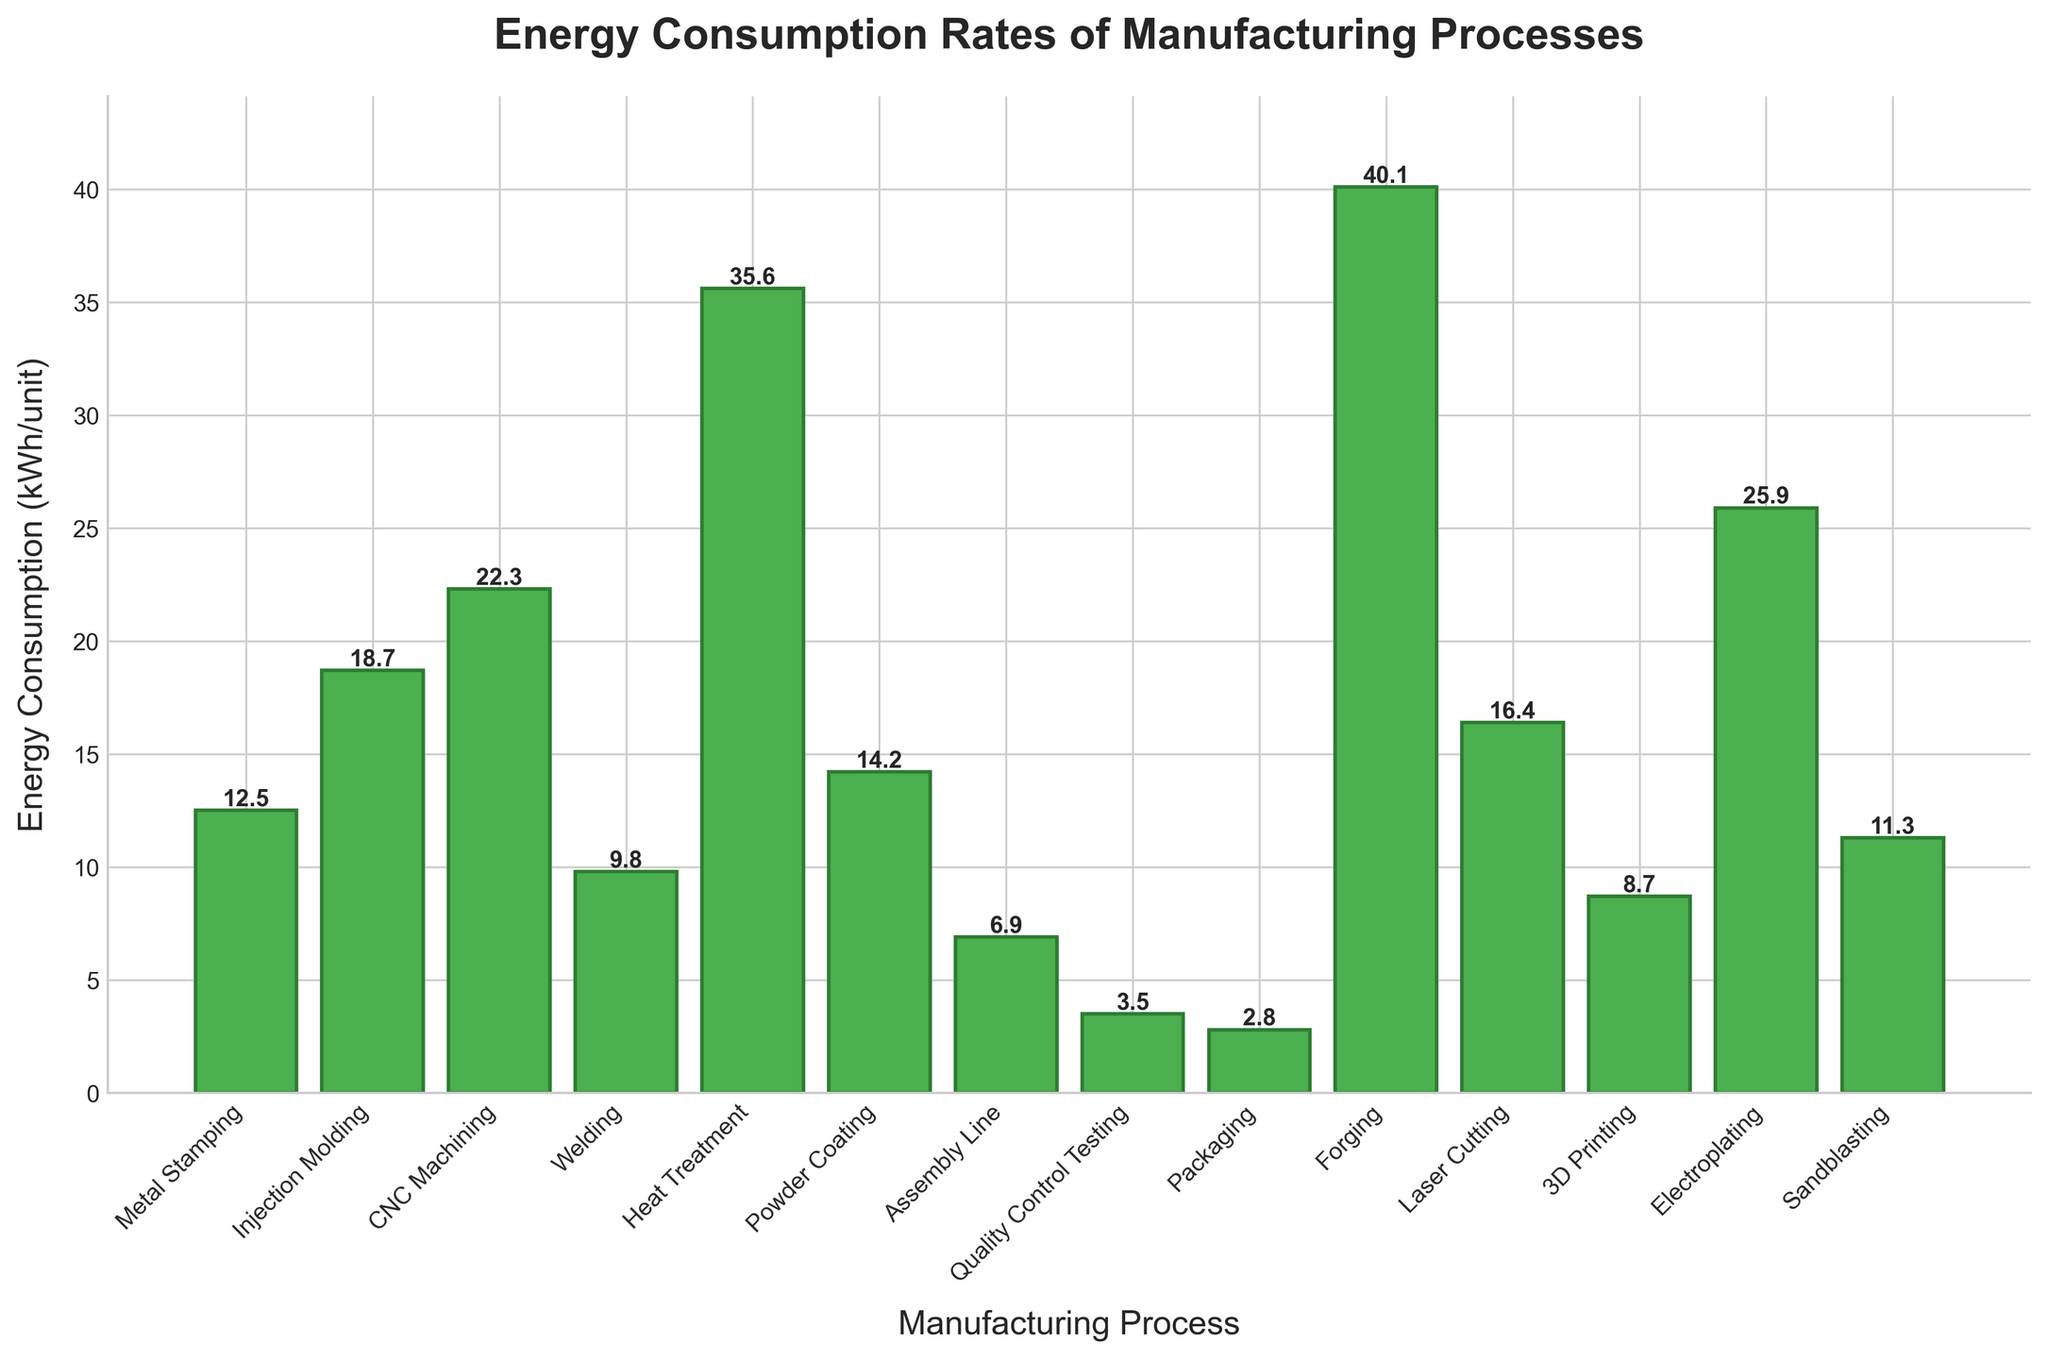What manufacturing process has the highest energy consumption? The bar representing Forging is the highest among all, indicating it has the highest energy consumption.
Answer: Forging Which process consumes less energy, Welding or Assembly Line? Compare the height of the bars for Welding and Assembly Line and note that Welding is higher.
Answer: Assembly Line What is the total energy consumption of the three least energy-intensive processes? Identify the three processes with the lowest bars: Packaging (2.8), Quality Control Testing (3.5), and Assembly Line (6.9). Sum them: 2.8 + 3.5 + 6.9 = 13.2.
Answer: 13.2 kWh/unit How much more energy does CNC Machining consume compared to 3D Printing? Find the difference in heights of the bars for CNC Machining (22.3) and 3D Printing (8.7): 22.3 - 8.7 = 13.6.
Answer: 13.6 kWh/unit Which process is the second highest in energy consumption? The second highest bar after Forging is Heat Treatment.
Answer: Heat Treatment What is the energy consumption difference between the processes with the highest and lowest rates? The highest is Forging (40.1 kWh/unit) and the lowest is Packaging (2.8 kWh/unit). Find the difference: 40.1 - 2.8 = 37.3.
Answer: 37.3 kWh/unit What is the average energy consumption of listed manufacturing processes? Sum all the energy consumption values and divide by the number of processes: (12.5 + 18.7 + 22.3 + 9.8 + 35.6 + 14.2 + 6.9 + 3.5 + 2.8 + 40.1 + 16.4 + 8.7 + 25.9 + 11.3) / 14 ≈ 16.8.
Answer: 16.8 kWh/unit Which process is represented by the green bar that is about halfway between Metal Stamping and Welding in terms of height? Identify the bar visually between Metal Stamping (12.5) and Welding (9.8), which is Sandblasting (11.3).
Answer: Sandblasting 